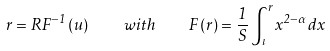<formula> <loc_0><loc_0><loc_500><loc_500>r = R F ^ { - 1 } \left ( u \right ) \quad w i t h \quad F \left ( r \right ) = \frac { 1 } { S } \int _ { \iota } ^ { r } x ^ { 2 - \alpha } d x</formula> 